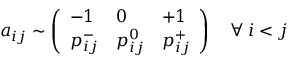Convert formula to latex. <formula><loc_0><loc_0><loc_500><loc_500>a _ { i j } \sim \left ( \begin{array} { l l l } { - 1 } & { 0 } & { + 1 } \\ { p _ { i j } ^ { - } } & { p _ { i j } ^ { 0 } } & { p _ { i j } ^ { + } } \end{array} \right ) \quad \forall \, i < j</formula> 